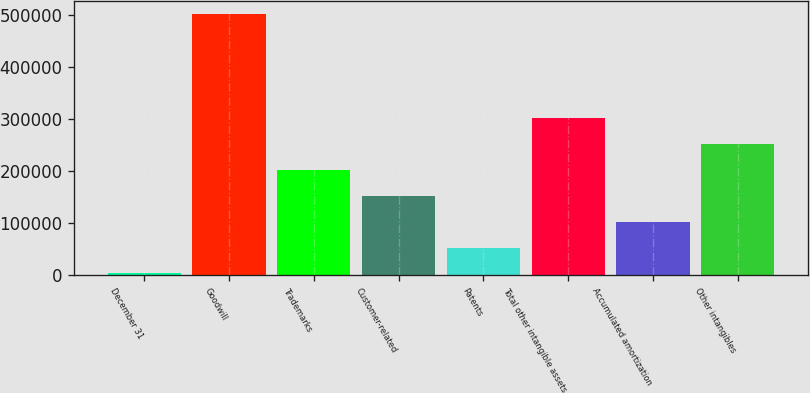Convert chart. <chart><loc_0><loc_0><loc_500><loc_500><bar_chart><fcel>December 31<fcel>Goodwill<fcel>Trademarks<fcel>Customer-related<fcel>Patents<fcel>Total other intangible assets<fcel>Accumulated amortization<fcel>Other intangibles<nl><fcel>2006<fcel>501955<fcel>201986<fcel>151991<fcel>52000.9<fcel>301975<fcel>101996<fcel>251980<nl></chart> 